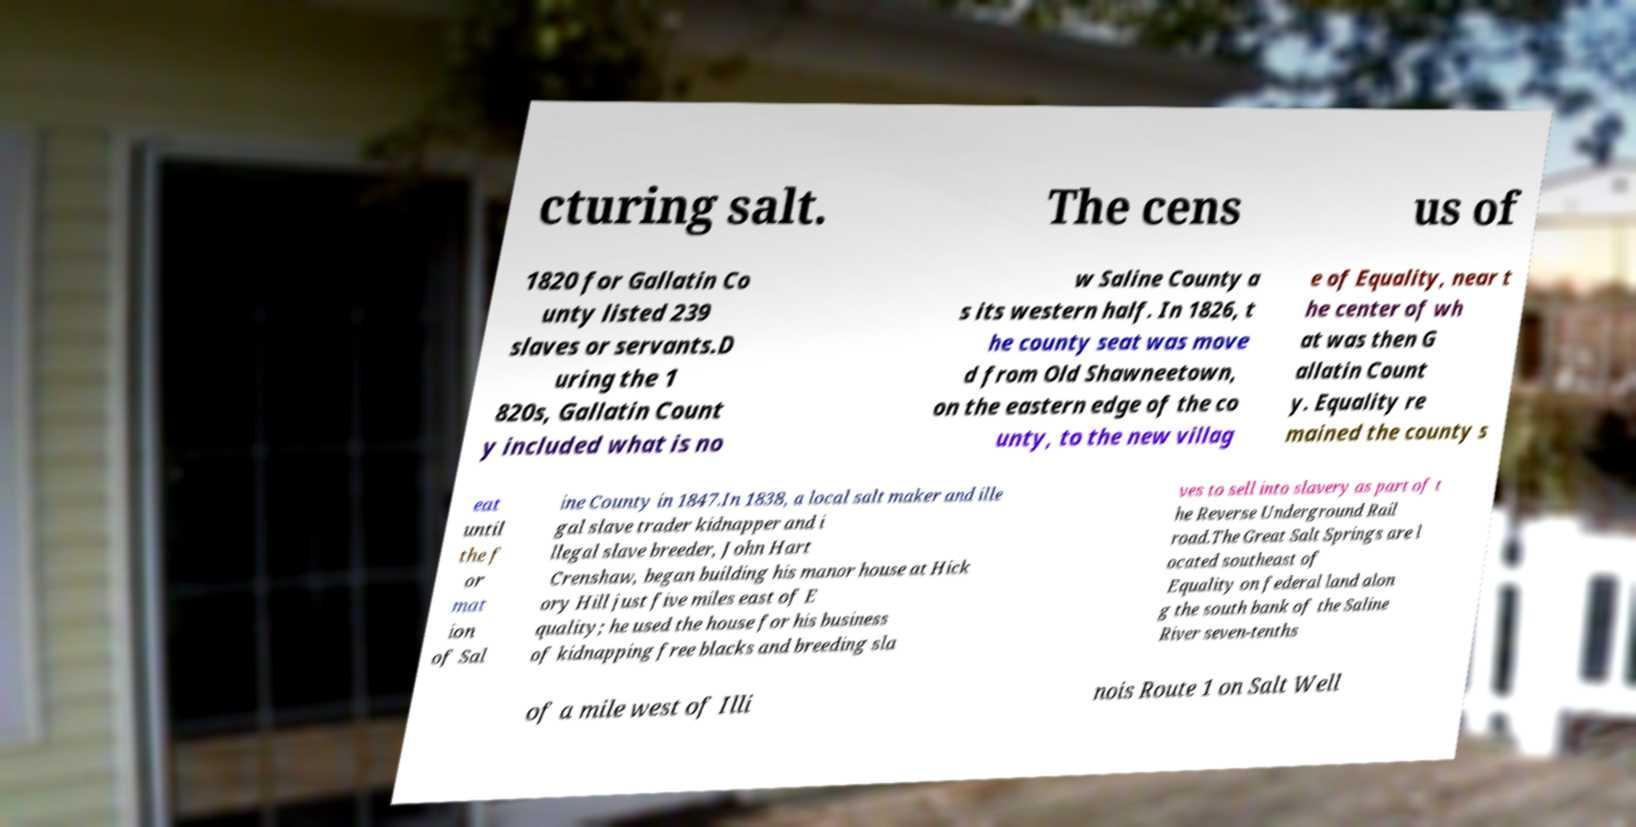I need the written content from this picture converted into text. Can you do that? cturing salt. The cens us of 1820 for Gallatin Co unty listed 239 slaves or servants.D uring the 1 820s, Gallatin Count y included what is no w Saline County a s its western half. In 1826, t he county seat was move d from Old Shawneetown, on the eastern edge of the co unty, to the new villag e of Equality, near t he center of wh at was then G allatin Count y. Equality re mained the county s eat until the f or mat ion of Sal ine County in 1847.In 1838, a local salt maker and ille gal slave trader kidnapper and i llegal slave breeder, John Hart Crenshaw, began building his manor house at Hick ory Hill just five miles east of E quality; he used the house for his business of kidnapping free blacks and breeding sla ves to sell into slavery as part of t he Reverse Underground Rail road.The Great Salt Springs are l ocated southeast of Equality on federal land alon g the south bank of the Saline River seven-tenths of a mile west of Illi nois Route 1 on Salt Well 